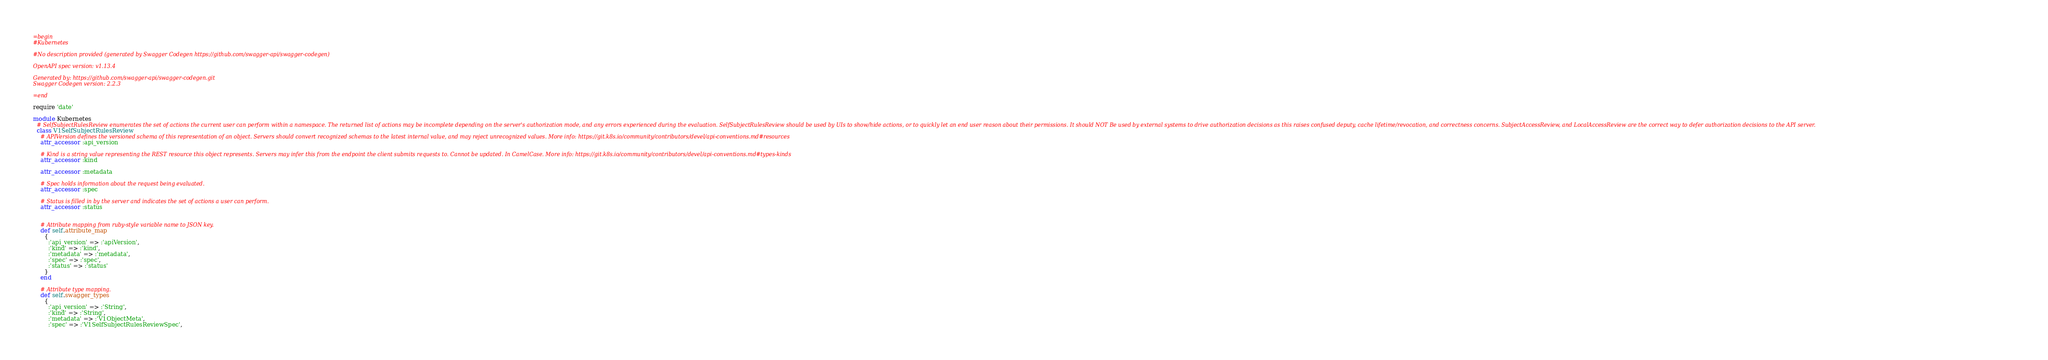Convert code to text. <code><loc_0><loc_0><loc_500><loc_500><_Ruby_>=begin
#Kubernetes

#No description provided (generated by Swagger Codegen https://github.com/swagger-api/swagger-codegen)

OpenAPI spec version: v1.13.4

Generated by: https://github.com/swagger-api/swagger-codegen.git
Swagger Codegen version: 2.2.3

=end

require 'date'

module Kubernetes
  # SelfSubjectRulesReview enumerates the set of actions the current user can perform within a namespace. The returned list of actions may be incomplete depending on the server's authorization mode, and any errors experienced during the evaluation. SelfSubjectRulesReview should be used by UIs to show/hide actions, or to quickly let an end user reason about their permissions. It should NOT Be used by external systems to drive authorization decisions as this raises confused deputy, cache lifetime/revocation, and correctness concerns. SubjectAccessReview, and LocalAccessReview are the correct way to defer authorization decisions to the API server.
  class V1SelfSubjectRulesReview
    # APIVersion defines the versioned schema of this representation of an object. Servers should convert recognized schemas to the latest internal value, and may reject unrecognized values. More info: https://git.k8s.io/community/contributors/devel/api-conventions.md#resources
    attr_accessor :api_version

    # Kind is a string value representing the REST resource this object represents. Servers may infer this from the endpoint the client submits requests to. Cannot be updated. In CamelCase. More info: https://git.k8s.io/community/contributors/devel/api-conventions.md#types-kinds
    attr_accessor :kind

    attr_accessor :metadata

    # Spec holds information about the request being evaluated.
    attr_accessor :spec

    # Status is filled in by the server and indicates the set of actions a user can perform.
    attr_accessor :status


    # Attribute mapping from ruby-style variable name to JSON key.
    def self.attribute_map
      {
        :'api_version' => :'apiVersion',
        :'kind' => :'kind',
        :'metadata' => :'metadata',
        :'spec' => :'spec',
        :'status' => :'status'
      }
    end

    # Attribute type mapping.
    def self.swagger_types
      {
        :'api_version' => :'String',
        :'kind' => :'String',
        :'metadata' => :'V1ObjectMeta',
        :'spec' => :'V1SelfSubjectRulesReviewSpec',</code> 